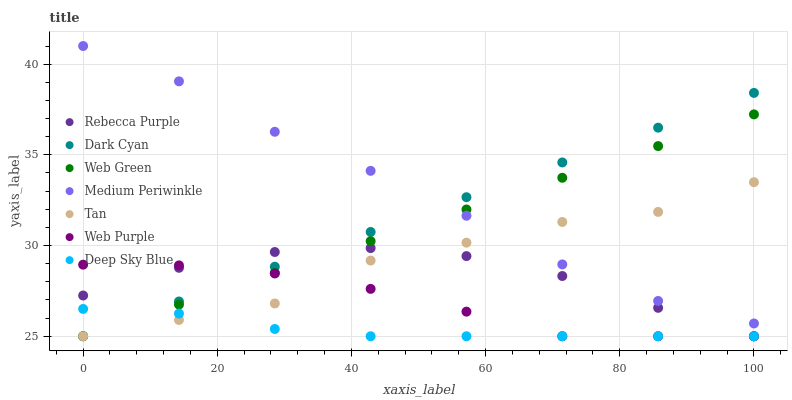Does Deep Sky Blue have the minimum area under the curve?
Answer yes or no. Yes. Does Medium Periwinkle have the maximum area under the curve?
Answer yes or no. Yes. Does Web Green have the minimum area under the curve?
Answer yes or no. No. Does Web Green have the maximum area under the curve?
Answer yes or no. No. Is Web Green the smoothest?
Answer yes or no. Yes. Is Tan the roughest?
Answer yes or no. Yes. Is Web Purple the smoothest?
Answer yes or no. No. Is Web Purple the roughest?
Answer yes or no. No. Does Web Green have the lowest value?
Answer yes or no. Yes. Does Medium Periwinkle have the highest value?
Answer yes or no. Yes. Does Web Green have the highest value?
Answer yes or no. No. Is Web Purple less than Medium Periwinkle?
Answer yes or no. Yes. Is Medium Periwinkle greater than Web Purple?
Answer yes or no. Yes. Does Web Purple intersect Deep Sky Blue?
Answer yes or no. Yes. Is Web Purple less than Deep Sky Blue?
Answer yes or no. No. Is Web Purple greater than Deep Sky Blue?
Answer yes or no. No. Does Web Purple intersect Medium Periwinkle?
Answer yes or no. No. 